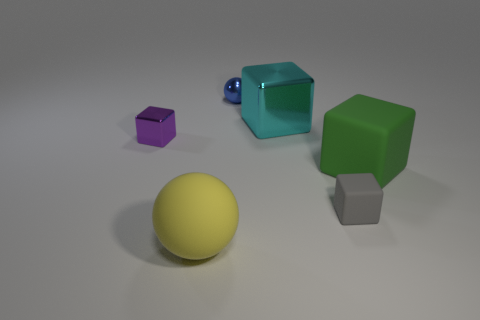Do the cyan block and the gray matte cube that is to the right of the tiny blue metallic object have the same size?
Offer a terse response. No. Are there any big green rubber cubes behind the big object that is in front of the big rubber object behind the yellow sphere?
Make the answer very short. Yes. There is a tiny cube that is behind the large green matte block; what is its material?
Provide a short and direct response. Metal. Does the blue metallic ball have the same size as the green rubber object?
Make the answer very short. No. There is a large thing that is on the left side of the large green cube and behind the tiny gray matte thing; what color is it?
Your answer should be very brief. Cyan. The green thing that is made of the same material as the tiny gray thing is what shape?
Keep it short and to the point. Cube. How many metallic cubes are to the left of the big yellow object and behind the purple shiny object?
Offer a terse response. 0. There is a large cyan block; are there any objects right of it?
Make the answer very short. Yes. Do the rubber object that is to the left of the small ball and the tiny metallic object that is right of the yellow matte object have the same shape?
Provide a short and direct response. Yes. How many objects are either tiny red shiny cylinders or big things in front of the tiny purple metallic cube?
Give a very brief answer. 2. 